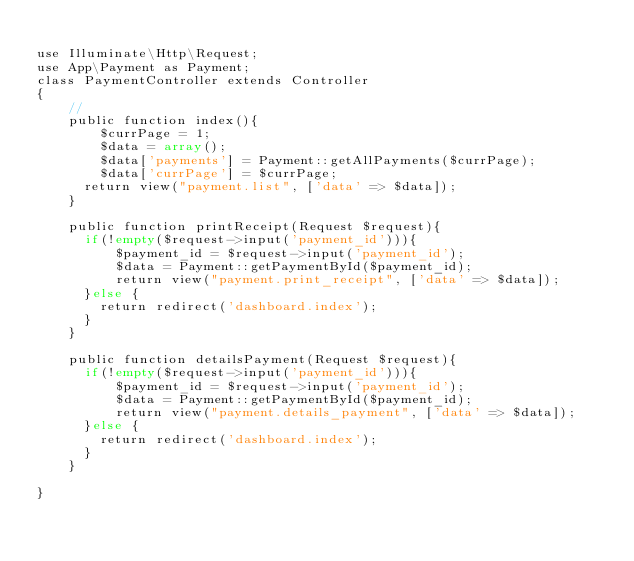Convert code to text. <code><loc_0><loc_0><loc_500><loc_500><_PHP_>
use Illuminate\Http\Request;
use App\Payment as Payment;
class PaymentController extends Controller
{
    //
    public function index(){
        $currPage = 1;
        $data = array();
        $data['payments'] = Payment::getAllPayments($currPage);
        $data['currPage'] = $currPage;
      return view("payment.list", ['data' => $data]);
    }

    public function printReceipt(Request $request){
      if(!empty($request->input('payment_id'))){
          $payment_id = $request->input('payment_id');
          $data = Payment::getPaymentById($payment_id);
          return view("payment.print_receipt", ['data' => $data]);
      }else {
        return redirect('dashboard.index');
      }
    }

    public function detailsPayment(Request $request){
      if(!empty($request->input('payment_id'))){
          $payment_id = $request->input('payment_id');
          $data = Payment::getPaymentById($payment_id);
          return view("payment.details_payment", ['data' => $data]);
      }else {
        return redirect('dashboard.index');
      }
    }

}
</code> 